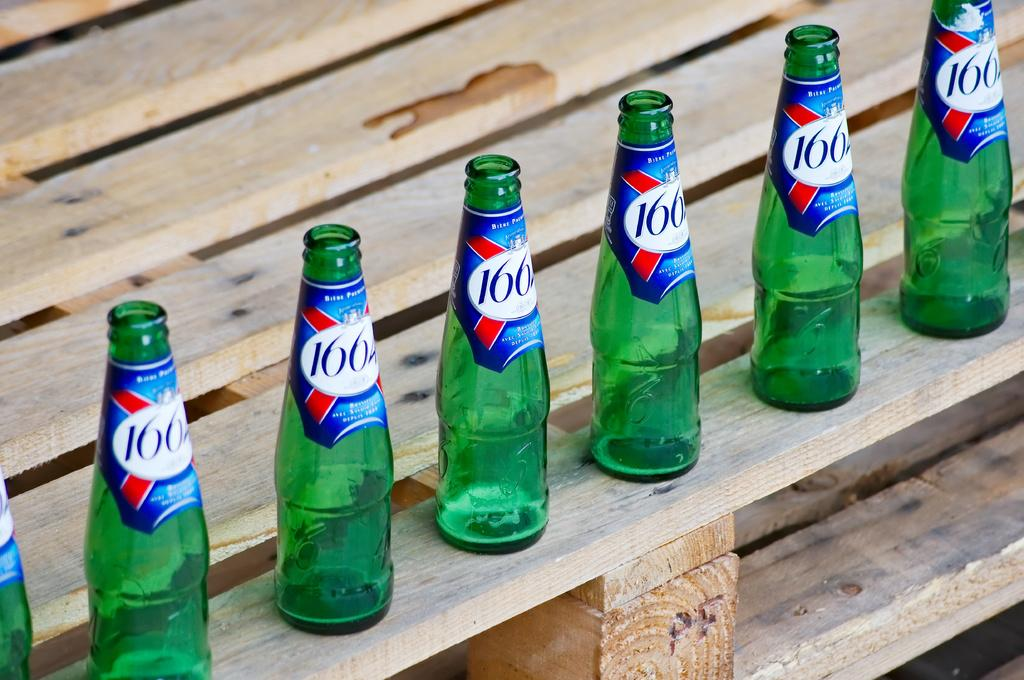<image>
Describe the image concisely. Many beers with the number 166 are next to each other 